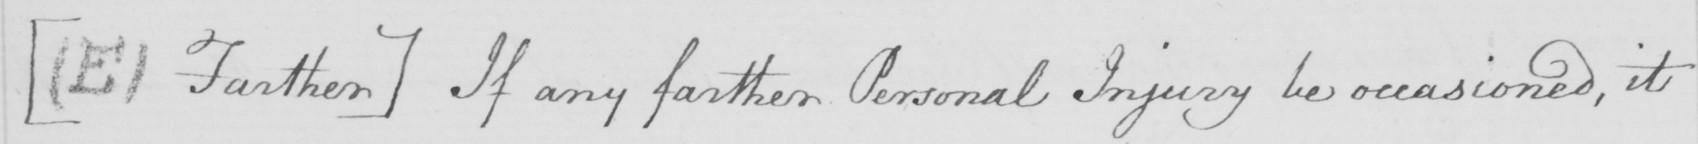What text is written in this handwritten line? [  ( E )  Farther ]  If any farther Personal Injury be occasioned , it 